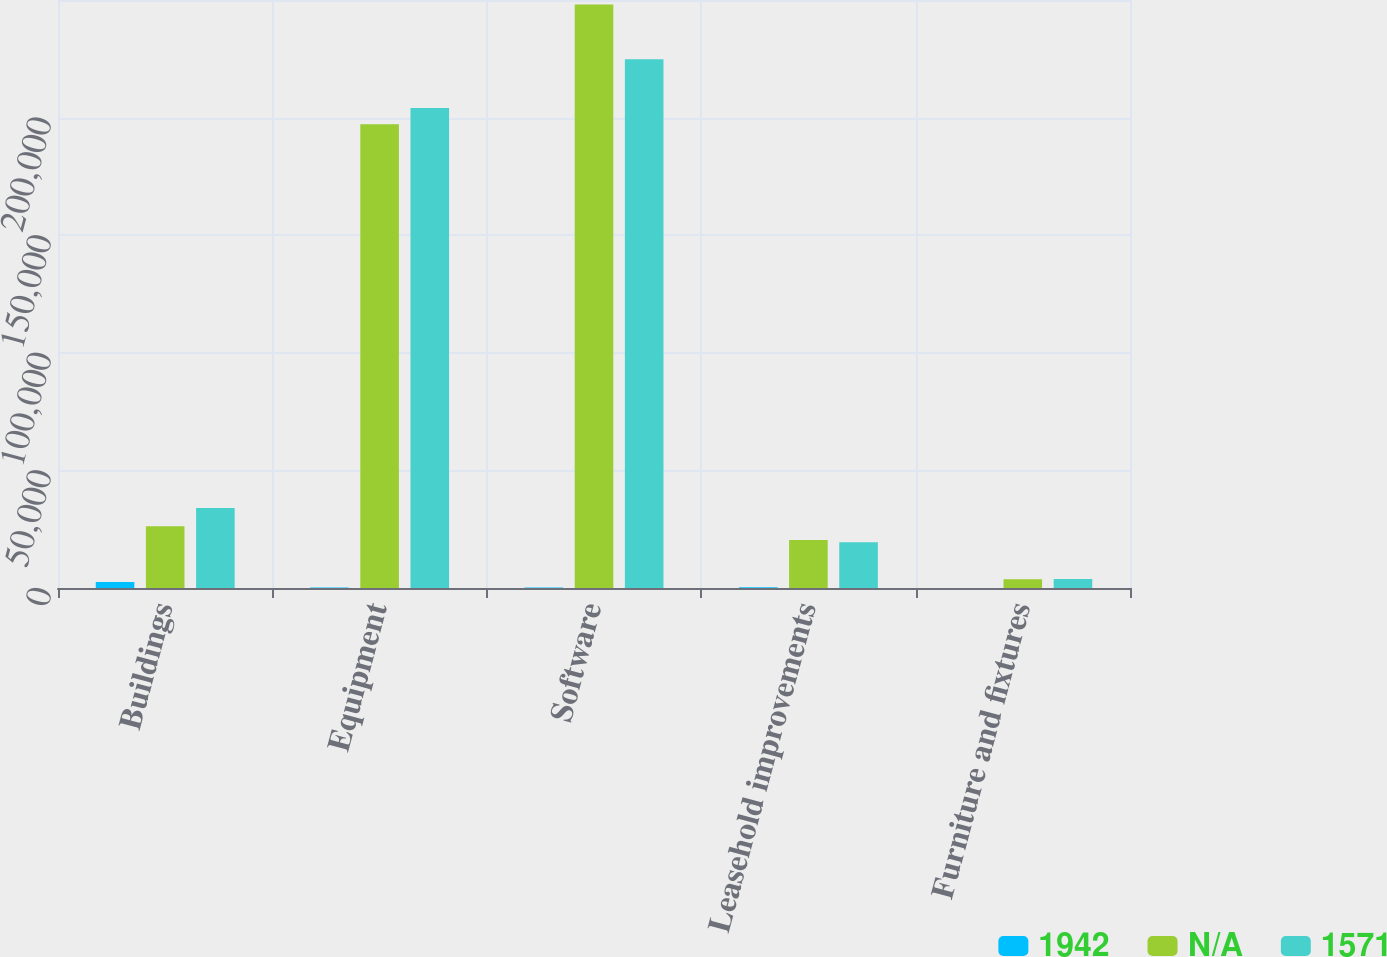Convert chart. <chart><loc_0><loc_0><loc_500><loc_500><stacked_bar_chart><ecel><fcel>Buildings<fcel>Equipment<fcel>Software<fcel>Leasehold improvements<fcel>Furniture and fixtures<nl><fcel>1942<fcel>2530<fcel>210<fcel>210<fcel>315<fcel>37<nl><fcel>nan<fcel>26236<fcel>197186<fcel>248137<fcel>20458<fcel>3705<nl><fcel>1571<fcel>33996<fcel>204102<fcel>224766<fcel>19399<fcel>3809<nl></chart> 